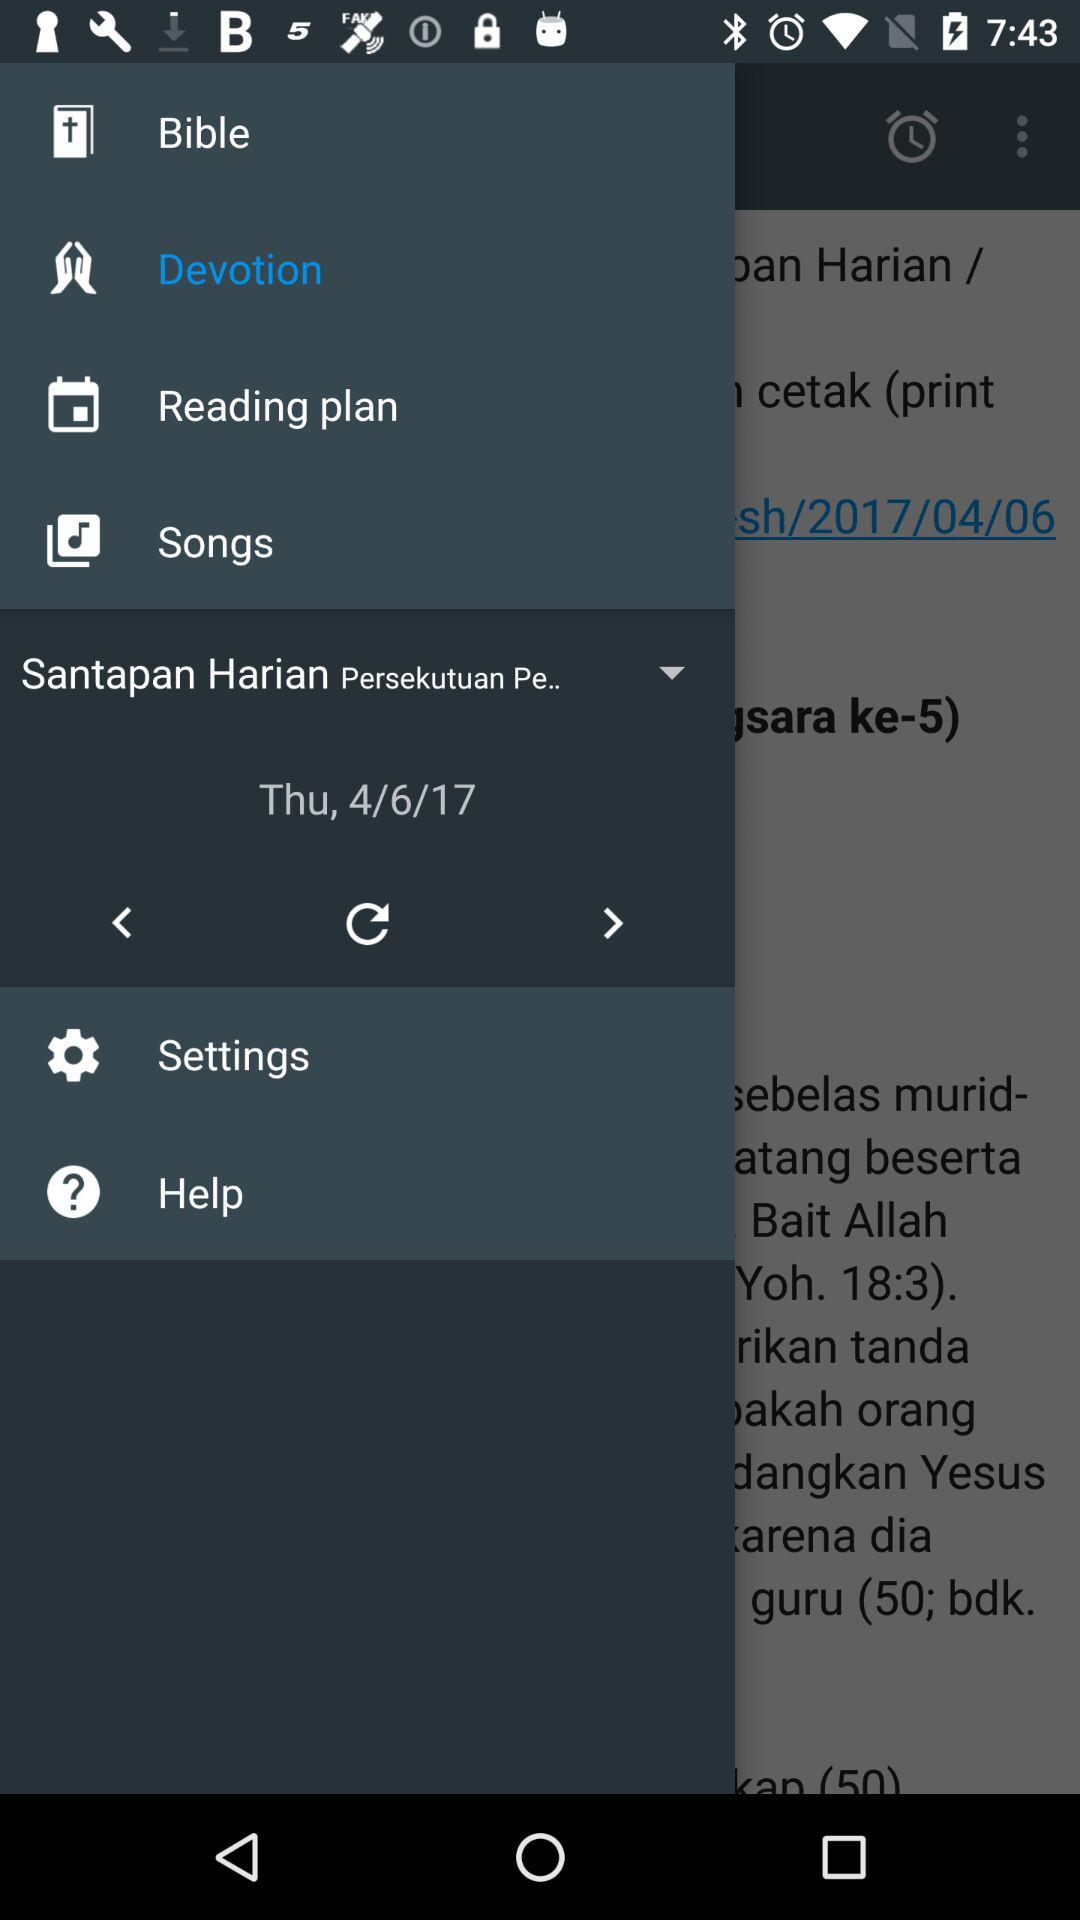What is the mentioned date? The mentioned date is Thursday, April 6, 2017. 